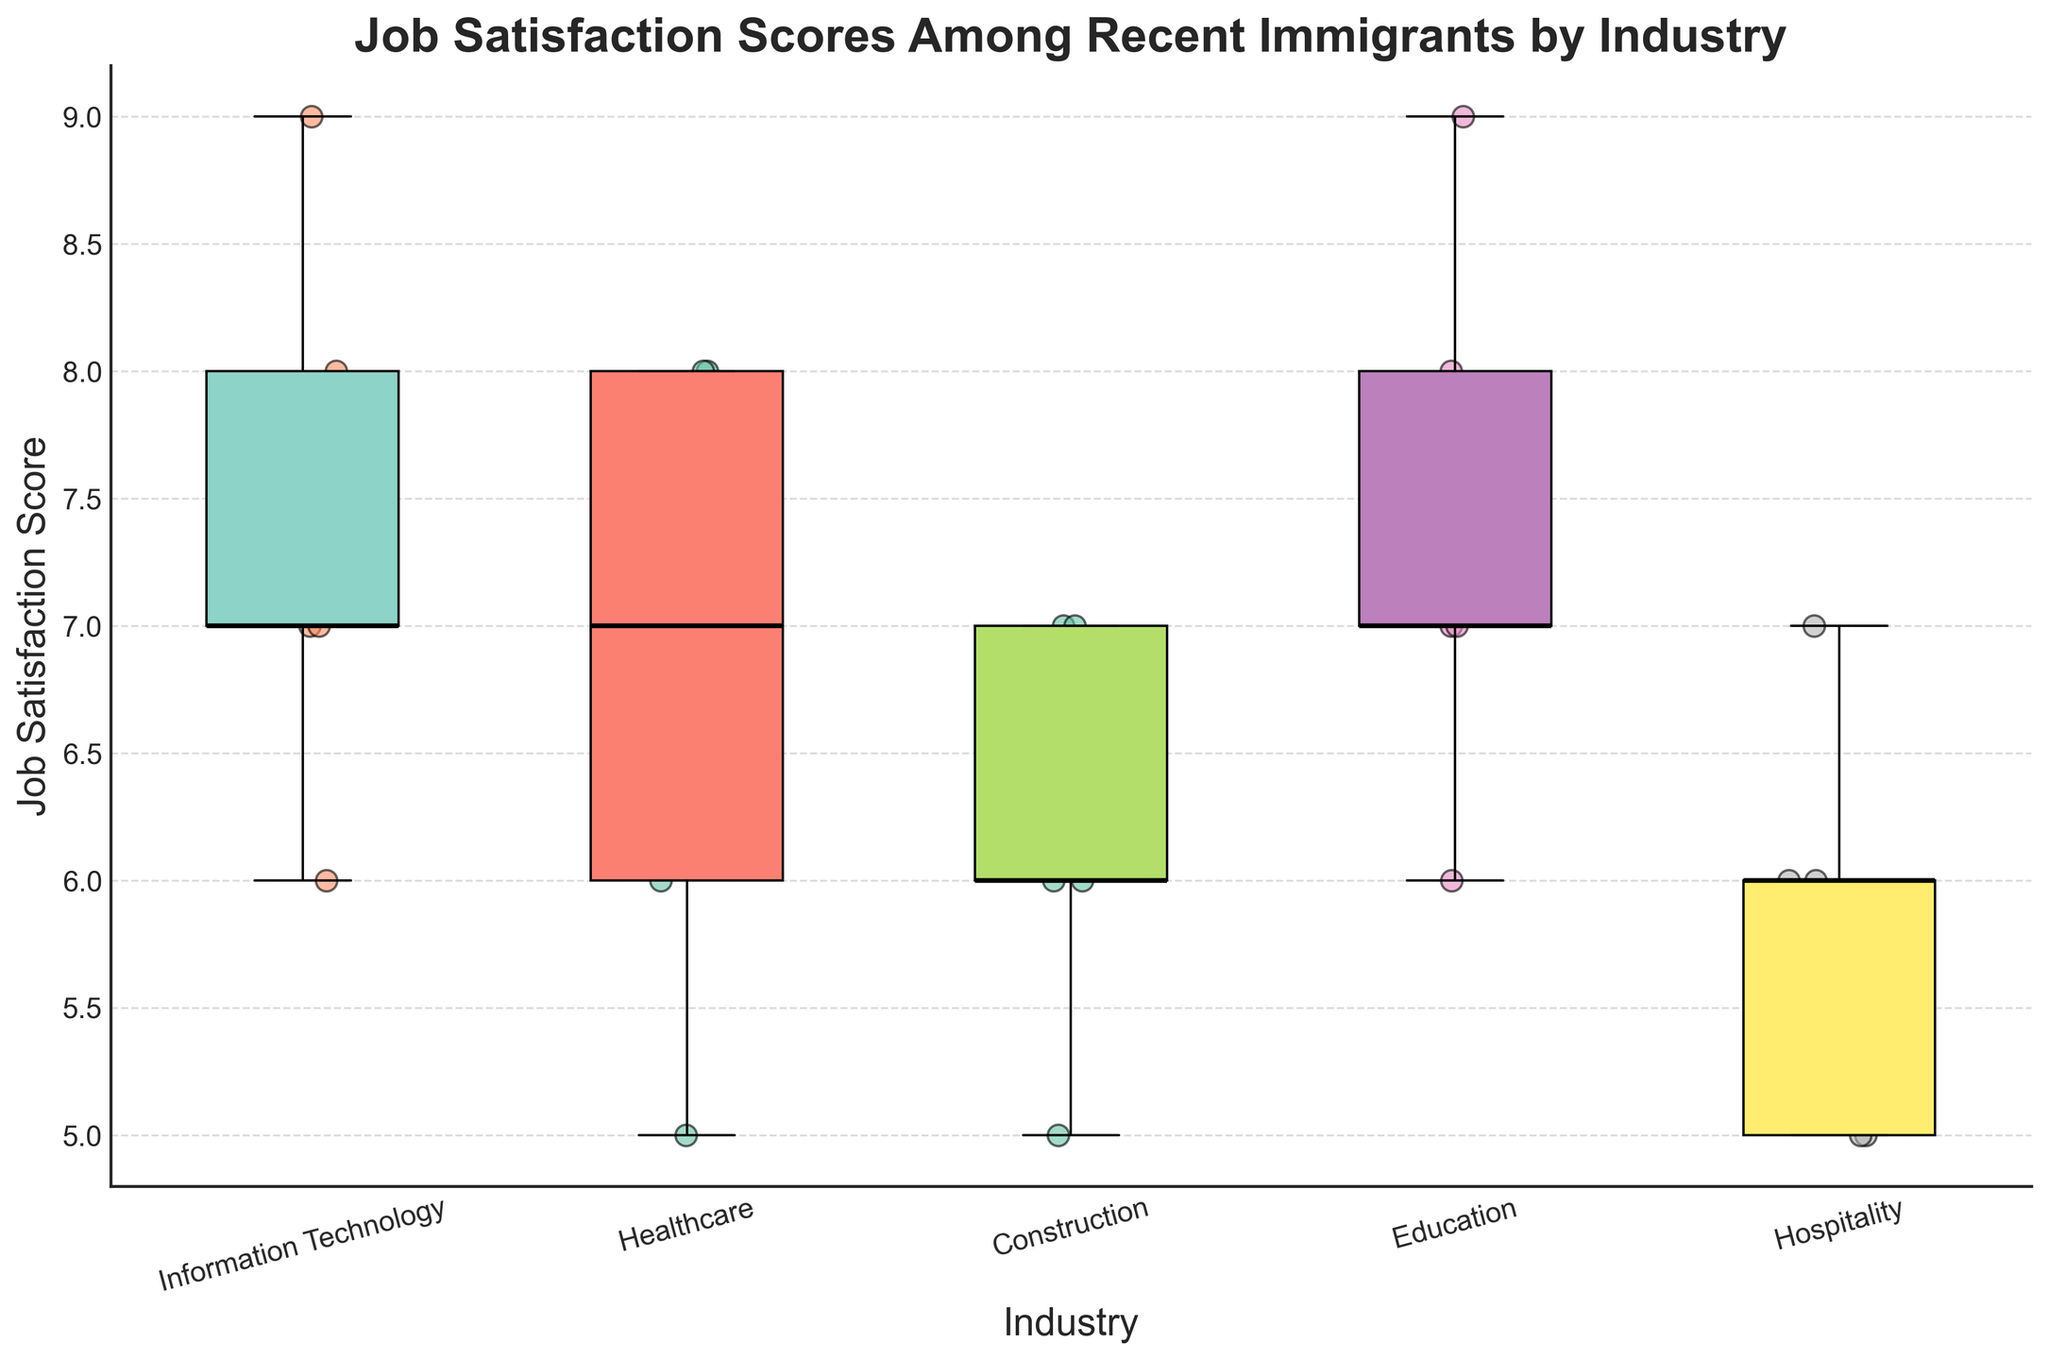What's the title of the plot? The title is usually displayed at the top of the plot. For this plot, it clearly states the main subject being visualized.
Answer: Job Satisfaction Scores Among Recent Immigrants by Industry Which industry appears to have the widest spread of job satisfaction scores? The spread of the data can be observed by looking at the length of the box and whiskers for each industry. The widest spread means the length from the minimum to the maximum value is the largest.
Answer: Hospitality What is the median job satisfaction score for the Education industry? In a box plot, the median is represented by the line inside the box. Looking at the Education industry box, the median line indicates the score.
Answer: 7 How many data points are there for the Healthcare industry? Each scatter point represents a data point. Count the number of scatter points within the Healthcare box plot.
Answer: 5 Which industry has the highest median job satisfaction score? Compare the median lines (the black line within the boxes) of all industries. The highest median line indicates the highest median job satisfaction score.
Answer: Education Are there any industries where an individual's job satisfaction score reached 9? If so, which ones? Check the scatter points for any that are at the value of 9. Then identify which industries these points belong to.
Answer: Information Technology, Education What is the job satisfaction score range for the Construction industry? For the range, find the minimum and maximum values represented by the whiskers or outermost points for the Construction industry. Then, calculate the difference.
Answer: 5 to 7 How does the job satisfaction score of Healthcare compare to Information Technology? Look at the median value lines for both Healthcare and Information Technology to compare their job satisfaction scores directly. Additionally, consider the spread (IQR) and any outliers for a comprehensive comparison.
Answer: Median scores: Healthcare is 7, IT is 7 Which industry shows the smallest variation in job satisfaction scores? The industry with the smallest variation will have the shortest whisker-to-whisker distance and a narrow box.
Answer: Healthcare Is there an industry where all individuals have a job satisfaction score below 8? Check the highest scatter points for each industry. Identify if there's any industry where all points are below the value of 8.
Answer: Construction, Hospitality 